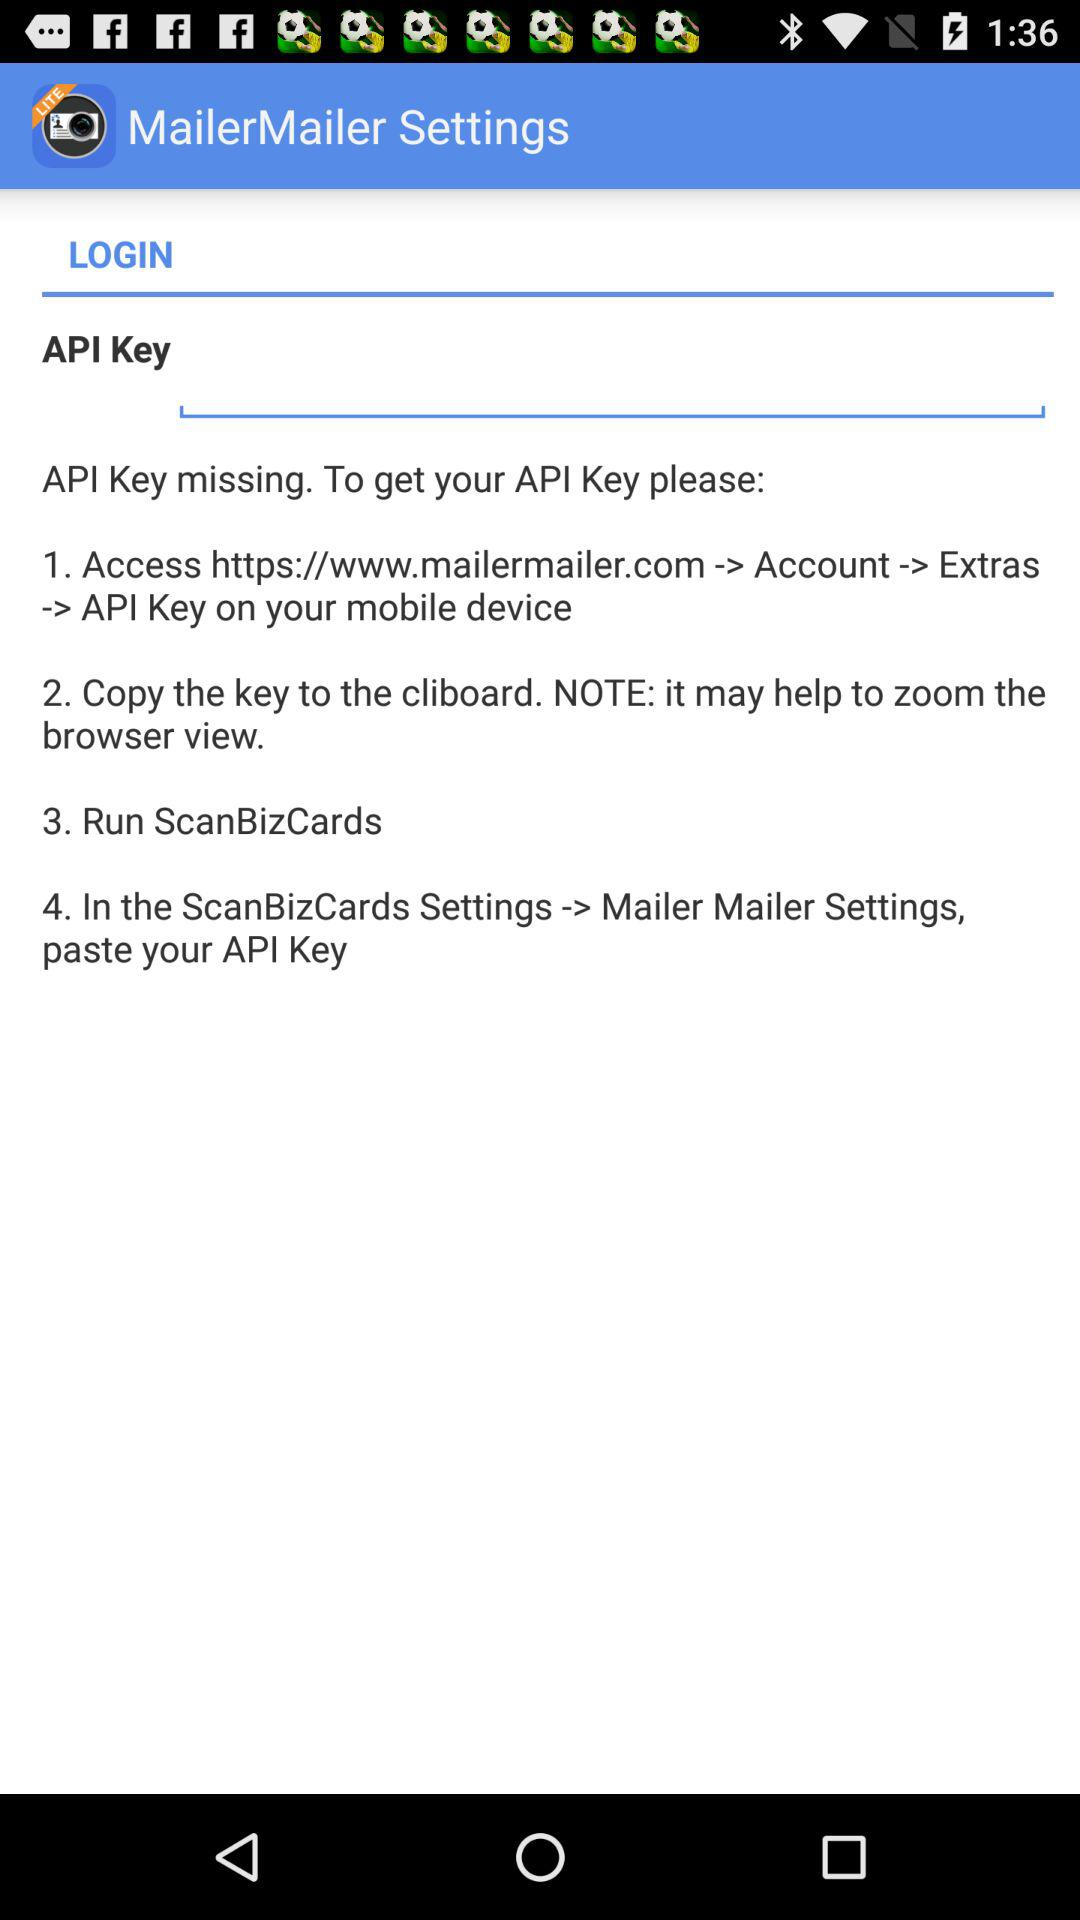What is the complete API key?
When the provided information is insufficient, respond with <no answer>. <no answer> 